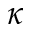Convert formula to latex. <formula><loc_0><loc_0><loc_500><loc_500>\kappa</formula> 